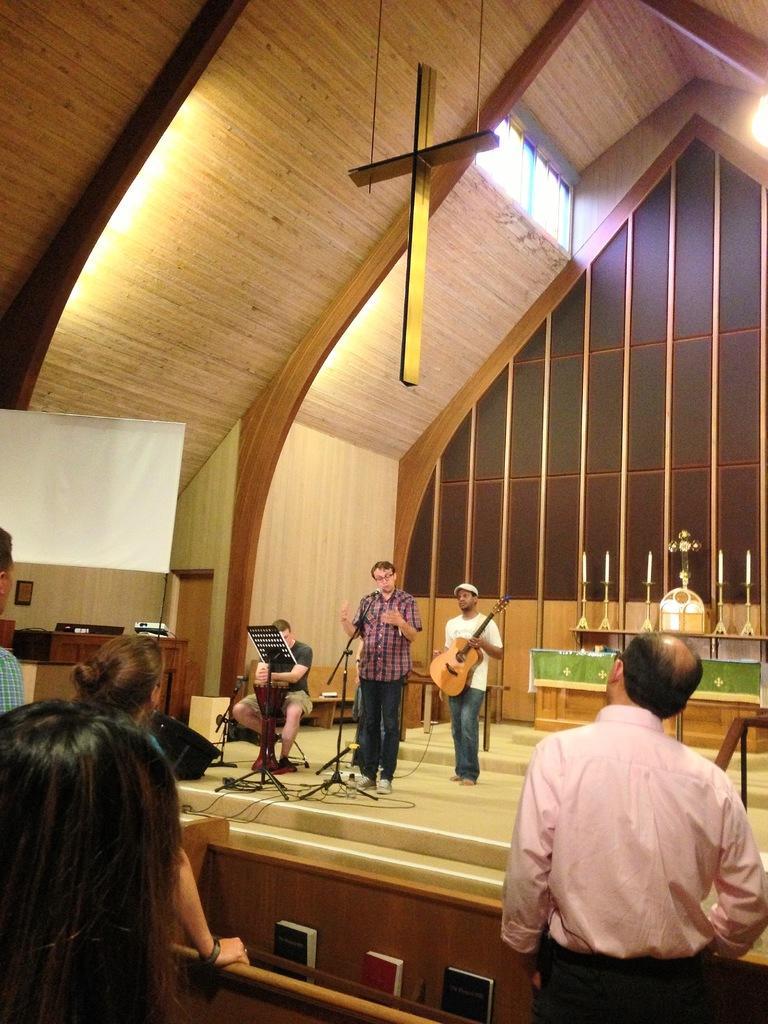Can you describe this image briefly? This image is taken indoors. At the bottom of the image there is a wooden piece. On the left side of the image a man and two women are standing. On the right side of the image there is a man. At the top of the image there is a roof with a few lights and there is a cross symbol. In the background there is a wall and there is a table with a few candles and candle holder on the dais. In the middle of the image a man is standing on the dais and playing music with a guitar. Another man is standing on the dais and singing and there's a mic. A man is sitting on the chair and playing music. 